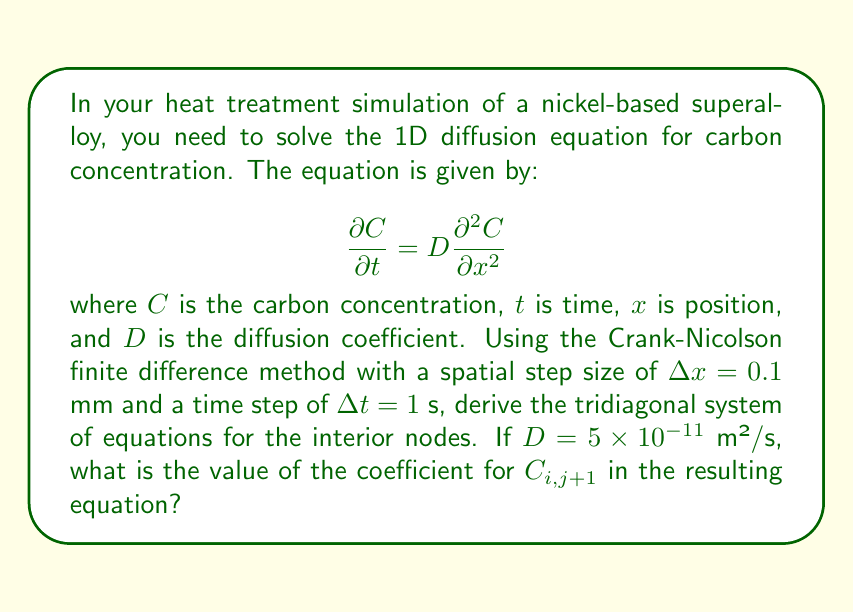Can you solve this math problem? To solve this problem, we'll follow these steps:

1) The Crank-Nicolson method is an implicit finite difference method that's second-order accurate in both time and space. It discretizes the diffusion equation as:

   $$\frac{C_{i,j+1} - C_{i,j}}{\Delta t} = \frac{D}{2} \left(\frac{C_{i+1,j} - 2C_{i,j} + C_{i-1,j}}{(\Delta x)^2} + \frac{C_{i+1,j+1} - 2C_{i,j+1} + C_{i-1,j+1}}{(\Delta x)^2}\right)$$

2) Rearranging this equation:

   $$C_{i,j+1} - C_{i,j} = \frac{D\Delta t}{2(\Delta x)^2} (C_{i+1,j} - 2C_{i,j} + C_{i-1,j} + C_{i+1,j+1} - 2C_{i,j+1} + C_{i-1,j+1})$$

3) Let's define $r = \frac{D\Delta t}{2(\Delta x)^2}$. Then:

   $$C_{i,j+1} - C_{i,j} = r(C_{i+1,j} - 2C_{i,j} + C_{i-1,j} + C_{i+1,j+1} - 2C_{i,j+1} + C_{i-1,j+1})$$

4) Rearranging to group terms at time step j+1:

   $$-rC_{i-1,j+1} + (1+2r)C_{i,j+1} - rC_{i+1,j+1} = rC_{i-1,j} + (1-2r)C_{i,j} + rC_{i+1,j}$$

5) This forms a tridiagonal system where the coefficient of $C_{i,j+1}$ is $(1+2r)$.

6) Now, let's calculate $r$:
   
   $r = \frac{D\Delta t}{2(\Delta x)^2} = \frac{(5 \times 10^{-11})(1)}{2(0.1 \times 10^{-3})^2} = 2.5 \times 10^{-3}$

7) Therefore, the coefficient of $C_{i,j+1}$ is:

   $1 + 2r = 1 + 2(2.5 \times 10^{-3}) = 1.005$
Answer: The coefficient of $C_{i,j+1}$ in the tridiagonal system is 1.005. 